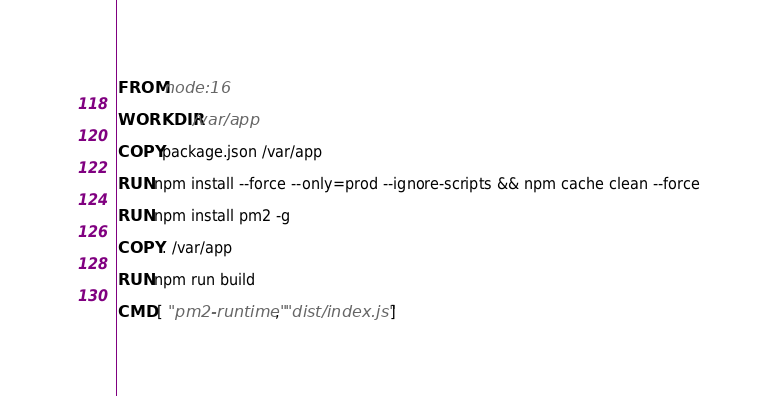Convert code to text. <code><loc_0><loc_0><loc_500><loc_500><_Dockerfile_>FROM node:16

WORKDIR /var/app

COPY package.json /var/app

RUN npm install --force --only=prod --ignore-scripts && npm cache clean --force

RUN npm install pm2 -g

COPY . /var/app

RUN npm run build

CMD [ "pm2-runtime", "dist/index.js" ]
</code> 